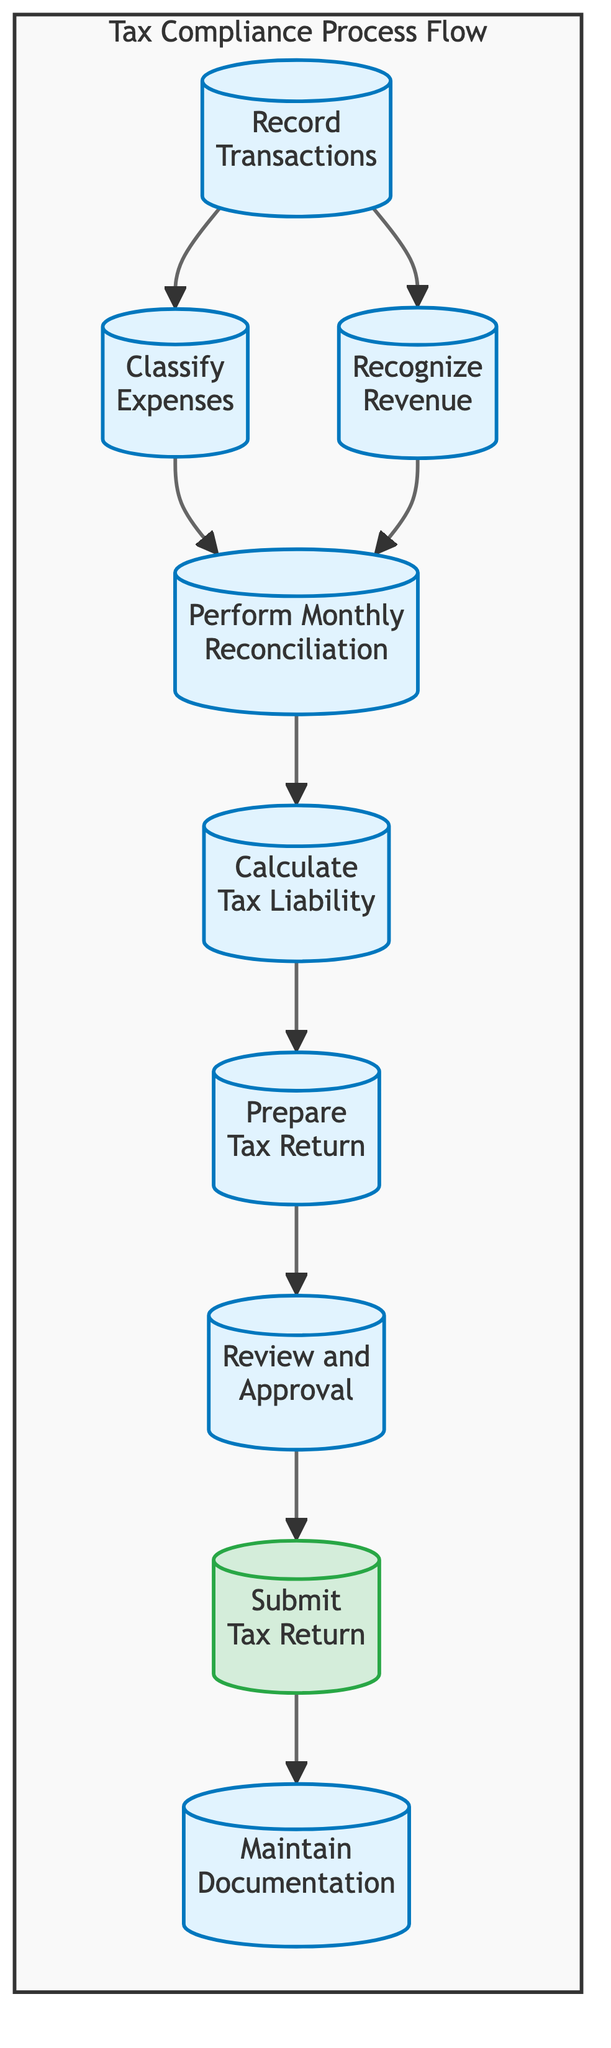What is the first step in the Tax Compliance Process Flow? The first step is "Record Transactions," which involves entering all buy and sell transactions into accounting software. This can be identified as the node at the top of the flow chart.
Answer: Record Transactions How many steps are there in the Tax Compliance Process Flow? The flow chart consists of a total of eight steps, which are represented by the individual nodes listed in the diagram.
Answer: Eight Which two steps occur just before "Calculate Tax Liability"? The steps that occur just before "Calculate Tax Liability" are "Perform Monthly Reconciliation" and "Recognize Revenue." These two steps lead directly to the calculation of tax liability in the flow sequence.
Answer: Perform Monthly Reconciliation and Recognize Revenue What is the final action in the Tax Compliance Process Flow? The final action is "Submit Tax Return," which is represented by the last node in the flow chart indicating the completion of the tax filing process.
Answer: Submit Tax Return What step directly follows "Prepare Tax Return"? The step that directly follows "Prepare Tax Return" is "Review and Approval," where tax documents are reviewed for accuracy before submission.
Answer: Review and Approval Which step involves storing tax-related documents? The step that involves storing tax-related documents is "Maintain Documentation," which is essential for future reference and compliance audits.
Answer: Maintain Documentation What step comes after "Review and Approval"? The step that comes after "Review and Approval" is "Submit Tax Return," marking the filing of the completed tax return with the tax authority.
Answer: Submit Tax Return What do "Classify Expenses" and "Recognize Revenue" have in common? Both "Classify Expenses" and "Recognize Revenue" are steps that follow the initial step of "Record Transactions," and they both contribute to the accurate recording of financial data necessary for tax compliance.
Answer: They follow "Record Transactions" and relate to accurate financial recording 